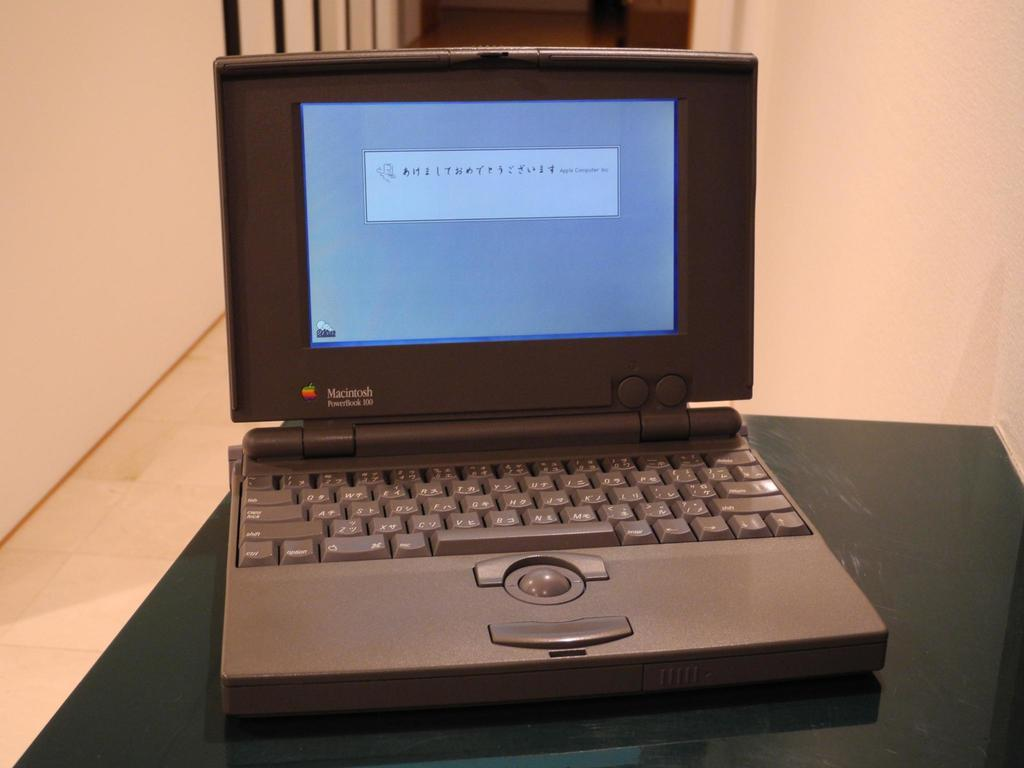<image>
Provide a brief description of the given image. A Macintosh PowerBook 100 is turned on and is displaying a message. 